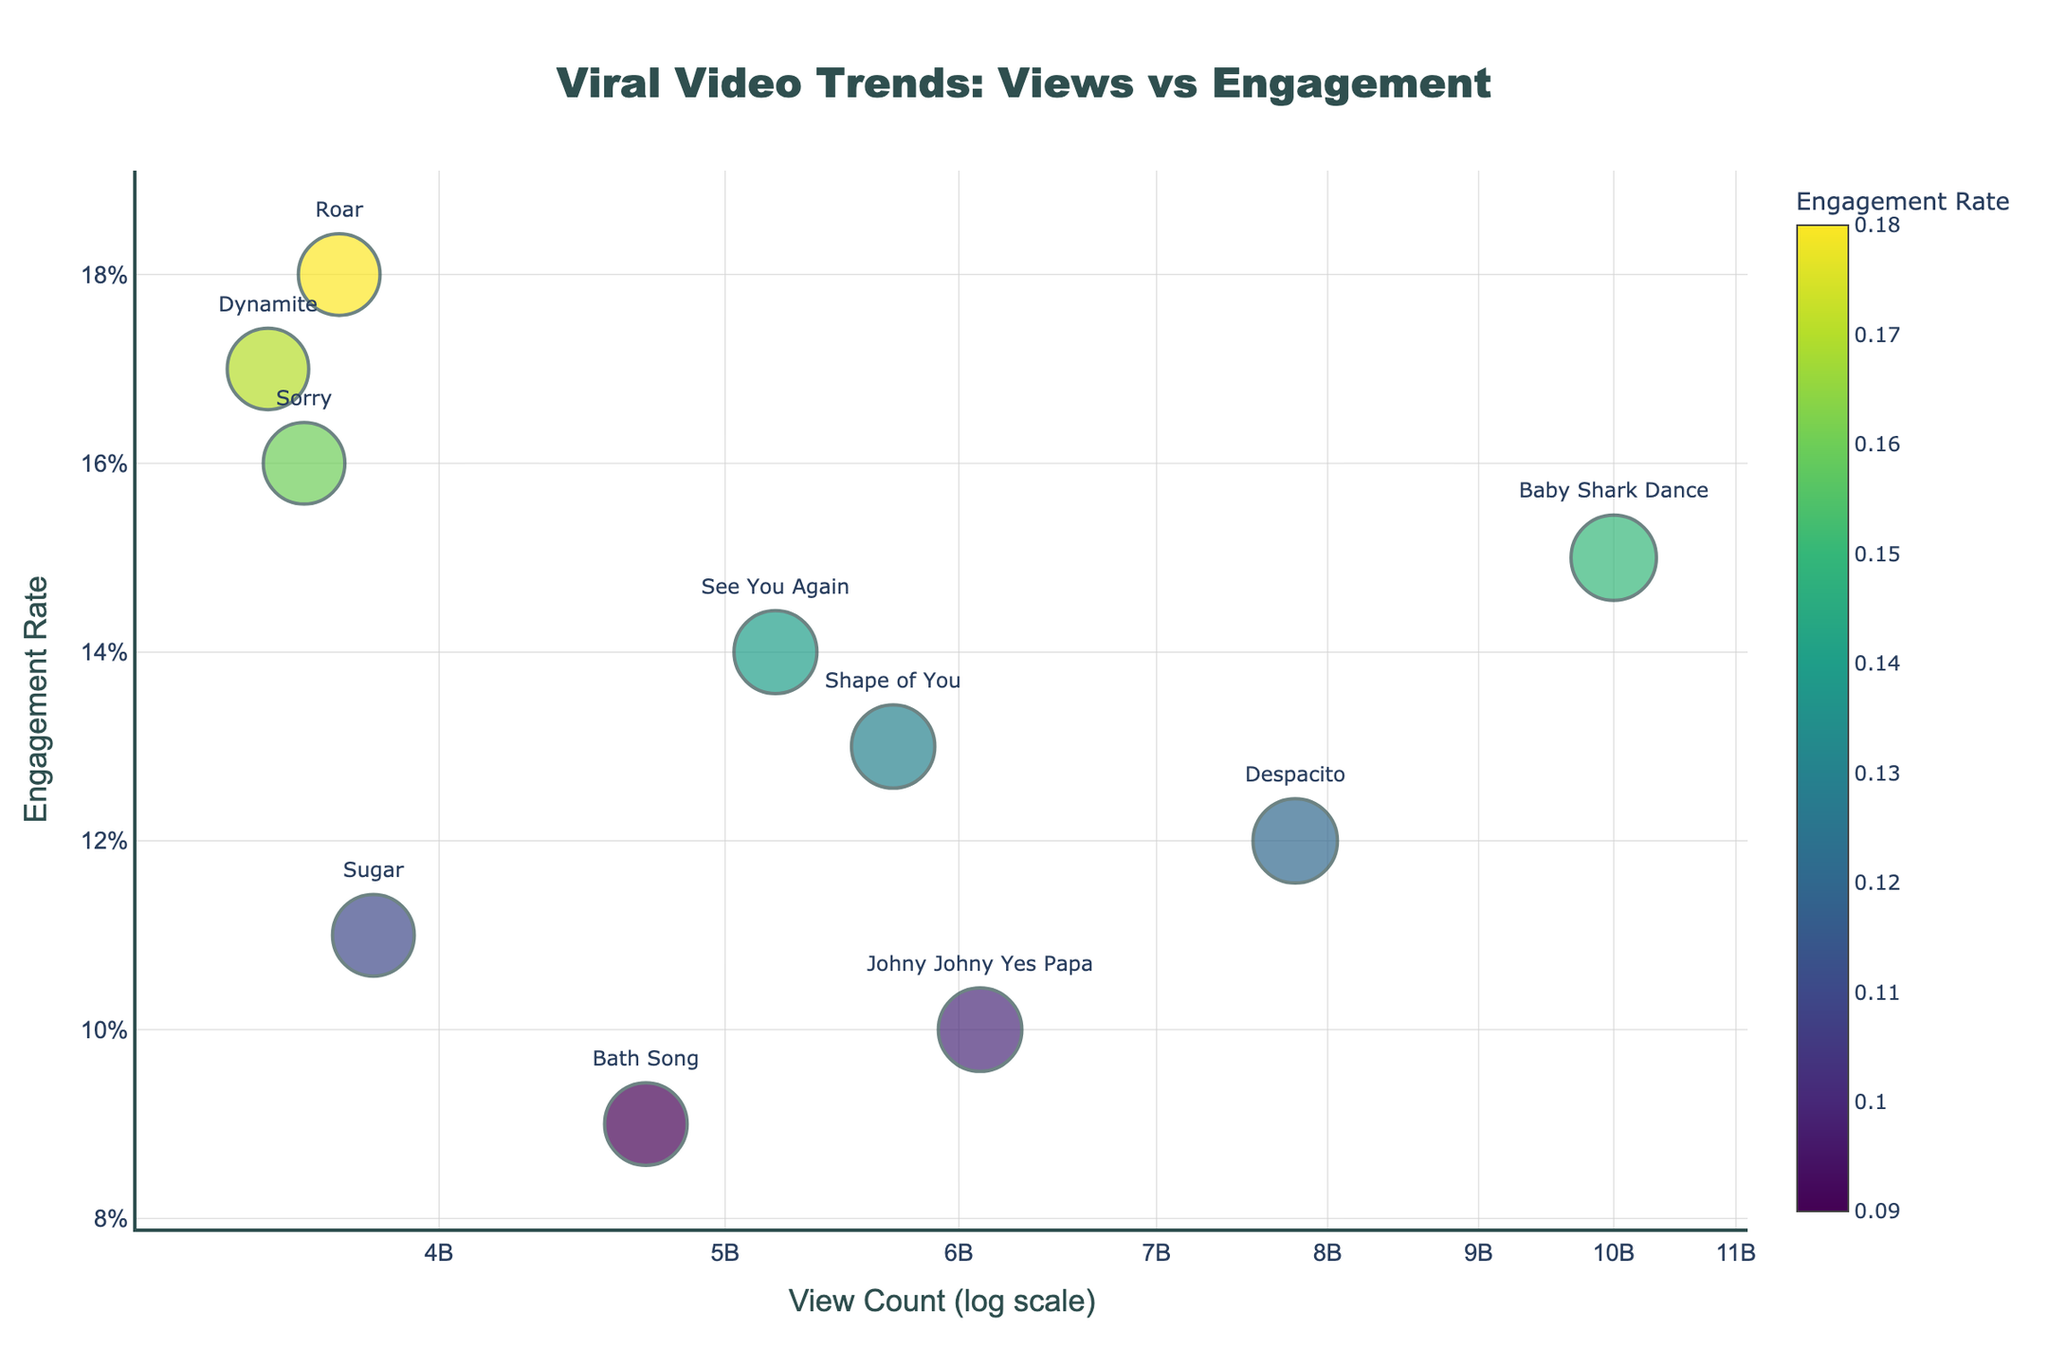How many total data points are there in the figure? Count the number of markers representing viral videos in the plot. Each marker corresponds to one video title in the dataset.
Answer: 10 What is the title of this figure? Look at the top of the figure where the title is displayed.
Answer: Viral Video Trends: Views vs Engagement Which video has the highest engagement rate? Identify the marker with the highest position on the y-axis labeled 'Engagement Rate'.
Answer: "Roar" What is the relationship between "Baby Shark Dance" and "Despacito" in terms of view count? Locate both markers on the x-axis labeled 'View Count'. Compare their positions to see which is higher.
Answer: "Baby Shark Dance" has more views Which video has the lowest engagement rate, and how does it compare in view count with "Shape of You"? Find the marker placed lowest on the y-axis for the lowest engagement rate. Then compare its x-axis position with that of "Shape of You."
Answer: "Bath Song" has the lowest engagement, and fewer views than "Shape of You" What's the average engagement rate of all videos? Calculate the sum of all engagement rates and divide by the number of videos.
Answer: 0.135 How does "Dynamite" rank in terms of engagement rate compared to "Sorry"? Locate both markers on the y-axis and compare their relative positions.
Answer: "Dynamite" has a higher engagement rate Which video has the closest view count to "See You Again," and what is that count? Identify the marker closest to "See You Again" on the x-axis and read its corresponding view count.
Answer: "Shape of You" with 5.7 billion views How does the engagement rate distribution change as view count increases? Observe the pattern and spread of markers on the plot to see if there is any noticeable trend.
Answer: No clear pattern Which video has a view count that's an order of magnitude higher than "Bath Song"? Compare the logarithmic differences in view counts between the videos. "Bath Song" has 4.7 billion views; an order of magnitude higher would be 47 billion, which no video in this dataset has.
Answer: None 